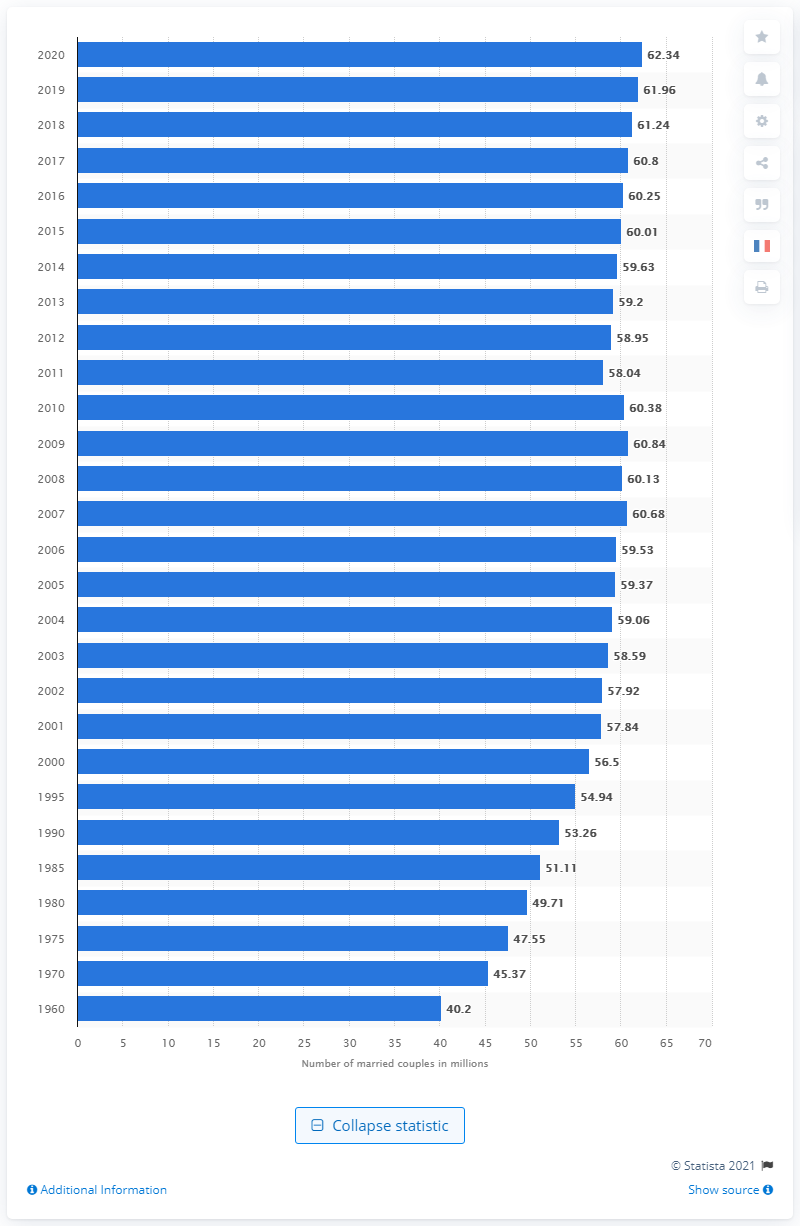Mention a couple of crucial points in this snapshot. In 2020, there were 62.34 married couples in the United States. In 1960, there were 40.2 million married couples in the United States. 